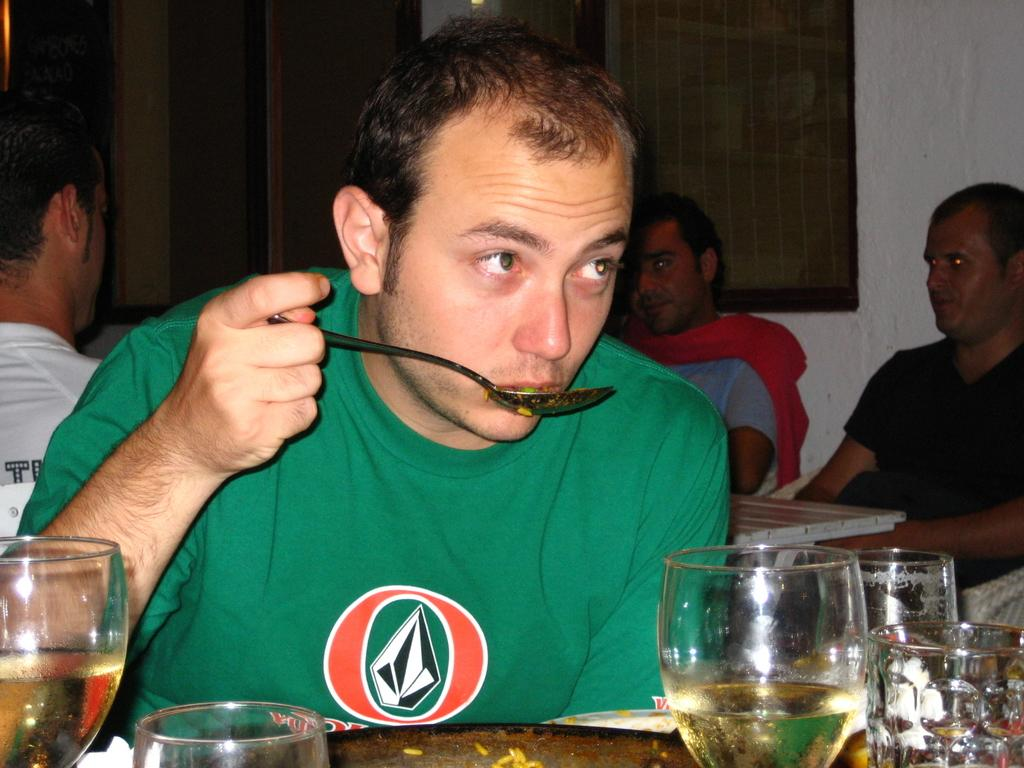How many people are in the image? There are four persons in the image. What are the persons doing in the image? The persons are sitting in front of tables. What objects can be seen on the tables? There are glasses on the tables. What is the man holding in the image? One man is holding a spoon. What can be seen in the background of the image? There is a wall in the background of the image. What type of butter is being served at the party in the image? There is no party or butter present in the image; it features four persons sitting in front of tables with glasses and a man holding a spoon. 